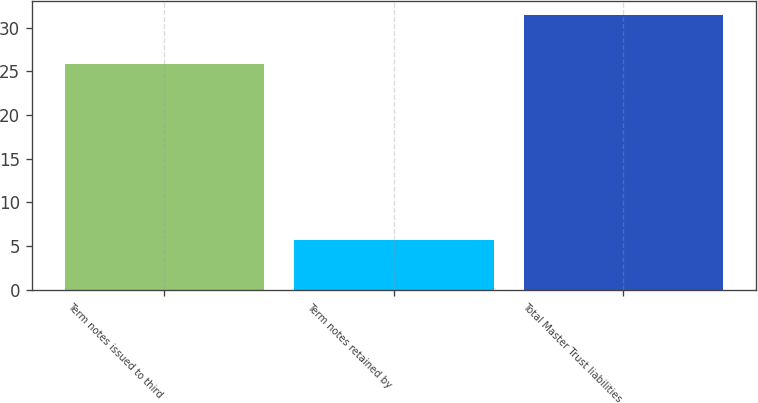<chart> <loc_0><loc_0><loc_500><loc_500><bar_chart><fcel>Term notes issued to third<fcel>Term notes retained by<fcel>Total Master Trust liabilities<nl><fcel>25.8<fcel>5.7<fcel>31.5<nl></chart> 